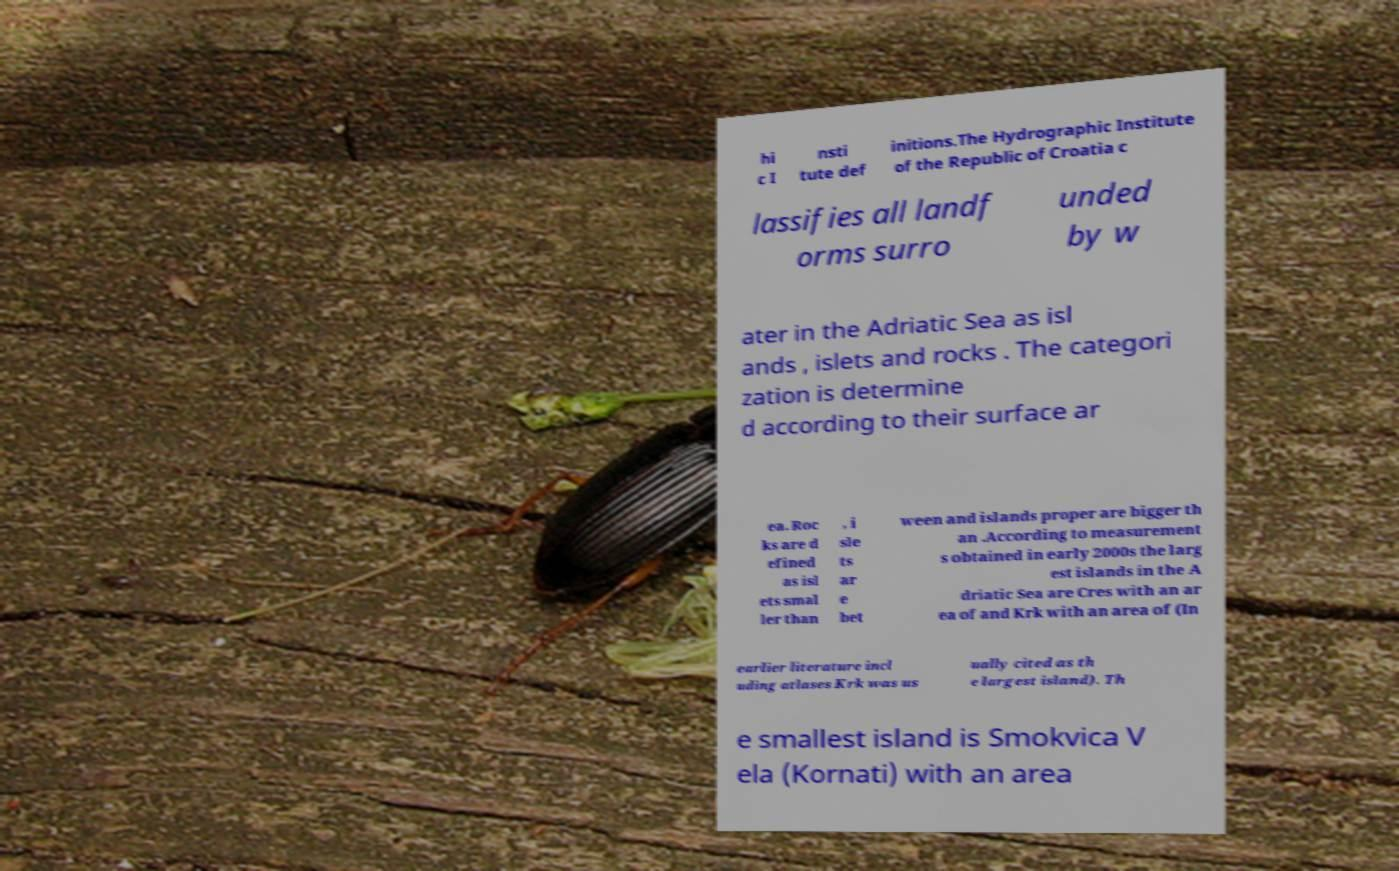Could you extract and type out the text from this image? hi c I nsti tute def initions.The Hydrographic Institute of the Republic of Croatia c lassifies all landf orms surro unded by w ater in the Adriatic Sea as isl ands , islets and rocks . The categori zation is determine d according to their surface ar ea. Roc ks are d efined as isl ets smal ler than , i sle ts ar e bet ween and islands proper are bigger th an .According to measurement s obtained in early 2000s the larg est islands in the A driatic Sea are Cres with an ar ea of and Krk with an area of (In earlier literature incl uding atlases Krk was us ually cited as th e largest island). Th e smallest island is Smokvica V ela (Kornati) with an area 